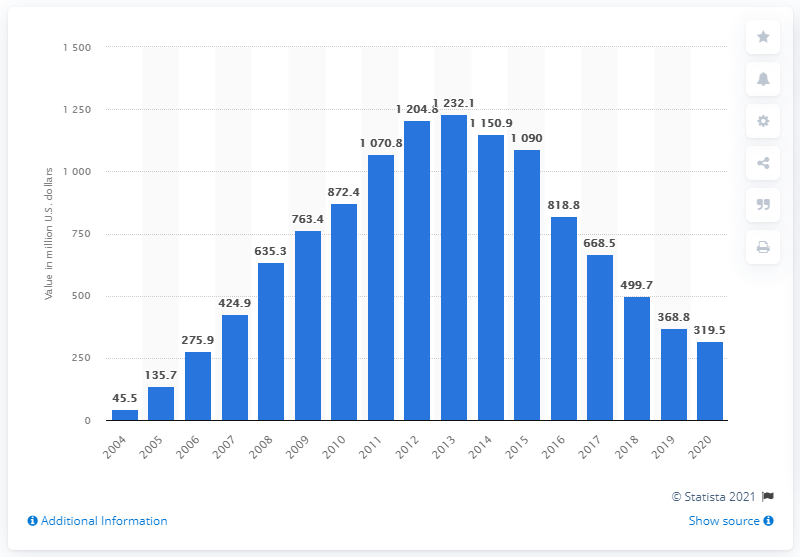Mention a couple of crucial points in this snapshot. In 2007, the value of digital music albums dropped to a similar level as it did in 1999. In 2020, digital music albums downloaded in the U.S. had a value of approximately 319.5.. 